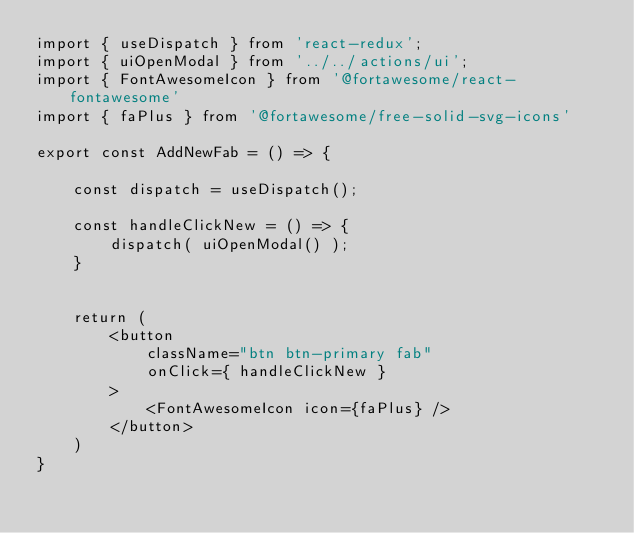<code> <loc_0><loc_0><loc_500><loc_500><_JavaScript_>import { useDispatch } from 'react-redux';
import { uiOpenModal } from '../../actions/ui';
import { FontAwesomeIcon } from '@fortawesome/react-fontawesome'
import { faPlus } from '@fortawesome/free-solid-svg-icons'

export const AddNewFab = () => {

    const dispatch = useDispatch();

    const handleClickNew = () => {
        dispatch( uiOpenModal() );
    }


    return (
        <button
            className="btn btn-primary fab"
            onClick={ handleClickNew }
        >
            <FontAwesomeIcon icon={faPlus} />
        </button>
    )
}</code> 